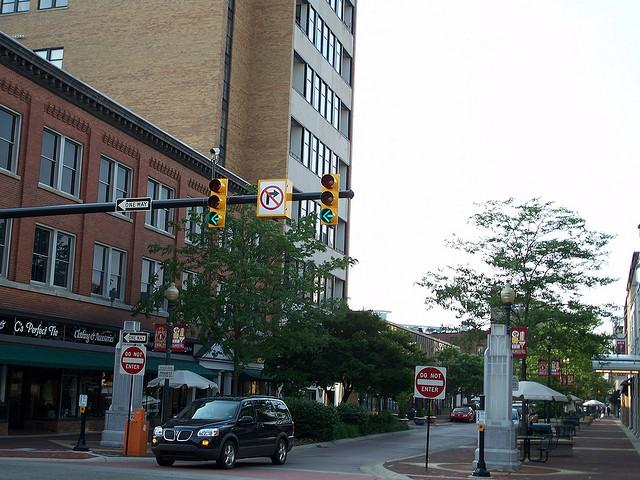Driving straight ahead might cause what?

Choices:
A) accident
B) flooded car
C) oil leak
D) flat tire accident 